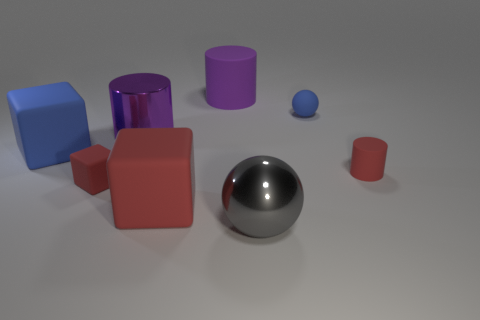There is a shiny cylinder behind the metal sphere; is it the same size as the tiny blue object?
Your answer should be compact. No. Is the small matte cylinder the same color as the small rubber cube?
Your response must be concise. Yes. How many red matte blocks are there?
Offer a terse response. 2. How many cylinders are either matte things or blue rubber objects?
Ensure brevity in your answer.  2. There is a red object right of the large metal ball; how many tiny objects are in front of it?
Provide a short and direct response. 1. Are the small red cylinder and the large gray thing made of the same material?
Provide a short and direct response. No. What size is the cylinder that is the same color as the tiny matte block?
Offer a very short reply. Small. Is there a tiny red cylinder made of the same material as the big blue thing?
Give a very brief answer. Yes. What is the color of the big shiny object that is behind the sphere that is in front of the large matte cube on the left side of the purple metal object?
Provide a short and direct response. Purple. What number of green things are either large rubber balls or cylinders?
Provide a short and direct response. 0. 